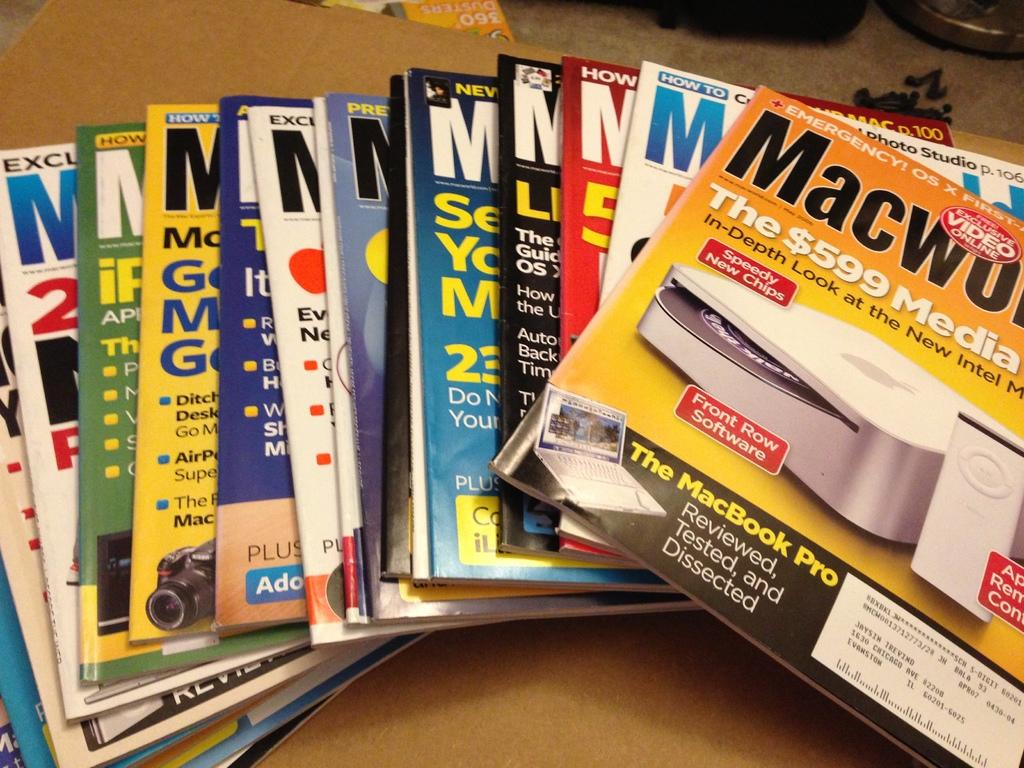<image>
Create a compact narrative representing the image presented. A stack of magazines includes one with an article about the MacBook Pro. 